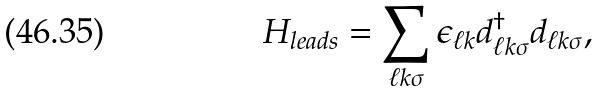<formula> <loc_0><loc_0><loc_500><loc_500>H _ { l e a d s } = \sum _ { \ell k \sigma } \epsilon _ { \ell k } d _ { \ell k \sigma } ^ { \dagger } d _ { \ell k \sigma } ,</formula> 